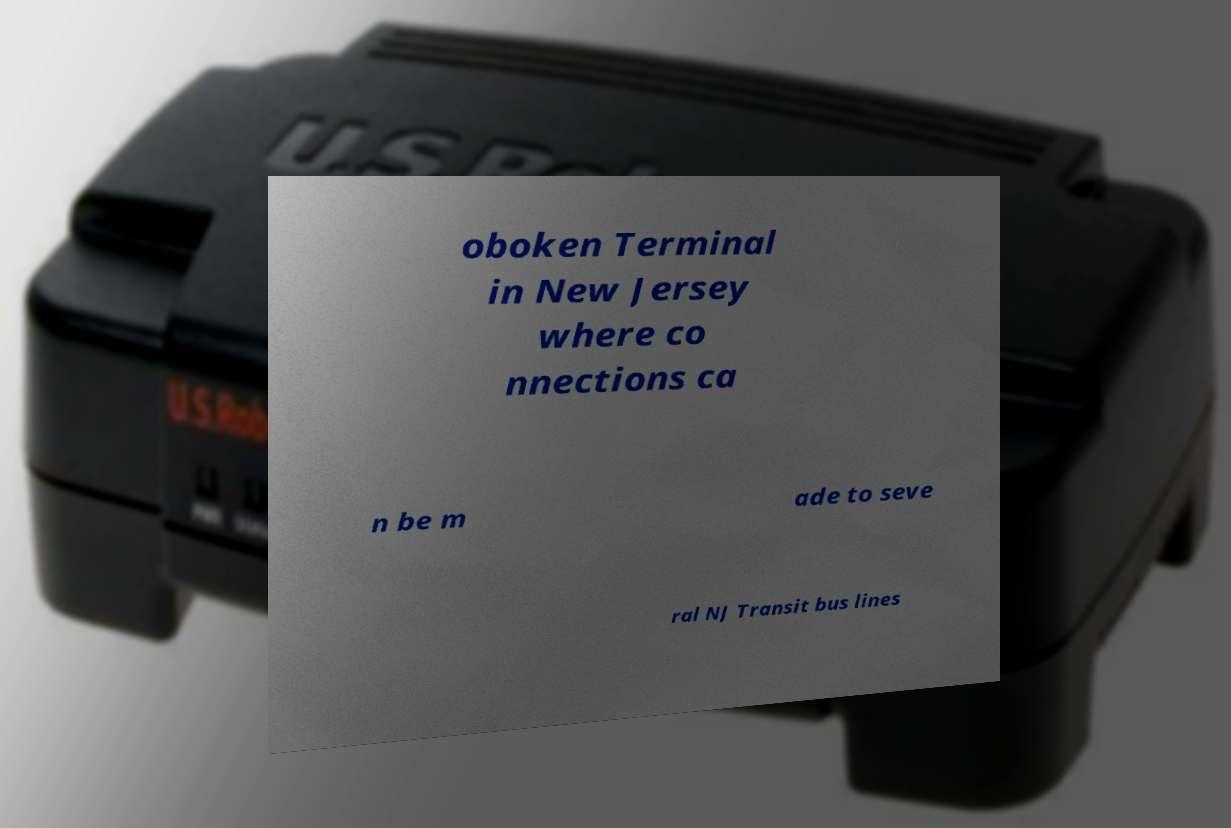For documentation purposes, I need the text within this image transcribed. Could you provide that? oboken Terminal in New Jersey where co nnections ca n be m ade to seve ral NJ Transit bus lines 